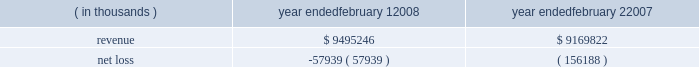For intangible assets subject to amortization , the estimated aggregate amortization expense for each of the five succeeding fiscal years is as follows : 2009 - $ 41.1 million , 2010 - $ 27.3 million , 2011 - $ 20.9 million , 2012 - $ 17.0 million , and 2013 - $ 12.0 million .
Fees and expenses related to the merger totaled $ 102.6 million , principally consisting of investment banking fees , legal fees and stock compensation ( $ 39.4 million as further discussed in note 10 ) , and are reflected in the 2007 results of operations .
Capitalized debt issuance costs as of the merger date of $ 87.4 million for merger-related financing were reflected in other long- term assets in the consolidated balance sheet .
The following represents the unaudited pro forma results of the company 2019s consolidated operations as if the merger had occurred on february 3 , 2007 and february 4 , 2006 , respectively , after giving effect to certain adjustments , including the depreciation and amortization of the assets acquired based on their estimated fair values and changes in interest expense resulting from changes in consolidated debt ( in thousands ) : ( in thousands ) year ended february 1 , year ended february 2 .
The pro forma information does not purport to be indicative of what the company 2019s results of operations would have been if the acquisition had in fact occurred at the beginning of the periods presented , and is not intended to be a projection of the company 2019s future results of operations .
Subsequent to the announcement of the merger agreement , the company and its directors , along with other parties , were named in seven putative class actions filed in tennessee state courts alleging claims for breach of fiduciary duty arising out of the proposed merger , all as described more fully under 201clegal proceedings 201d in note 8 below .
Strategic initiatives during 2006 , the company began implementing certain strategic initiatives related to its historical inventory management and real estate strategies , as more fully described below .
Inventory management in november 2006 , the company undertook an initiative to discontinue its historical inventory packaway model for virtually all merchandise by the end of fiscal 2007 .
Under the packaway model , certain unsold inventory items ( primarily seasonal merchandise ) were stored on-site and returned to the sales floor until the items were eventually sold , damaged or discarded .
Through end-of-season and other markdowns , this initiative resulted in the elimination of seasonal , home products and basic clothing packaway merchandise to allow for increased levels of newer , current-season merchandise .
In connection with this strategic change , in the third quarter of 2006 the company recorded a reserve for lower of cost or market inventory .
What was the total estimated aggregate amortization expense for each of the five succeeding fiscal years from 2009 to 2013 in millions? 
Rationale: this the sum of all amounts associated
Computations: ((((41.1 + 27.3) + 20.9) + 17.0) + 12.0)
Answer: 118.3. 